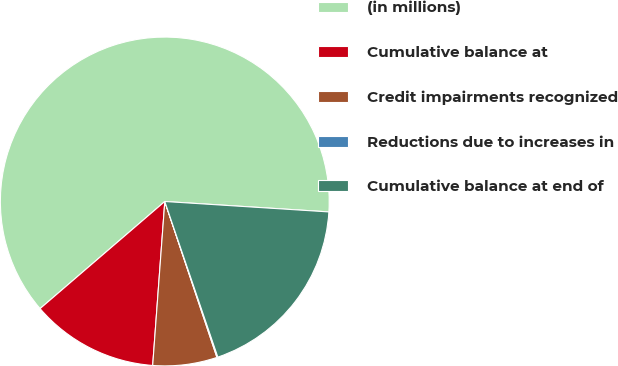Convert chart to OTSL. <chart><loc_0><loc_0><loc_500><loc_500><pie_chart><fcel>(in millions)<fcel>Cumulative balance at<fcel>Credit impairments recognized<fcel>Reductions due to increases in<fcel>Cumulative balance at end of<nl><fcel>62.3%<fcel>12.53%<fcel>6.31%<fcel>0.09%<fcel>18.76%<nl></chart> 